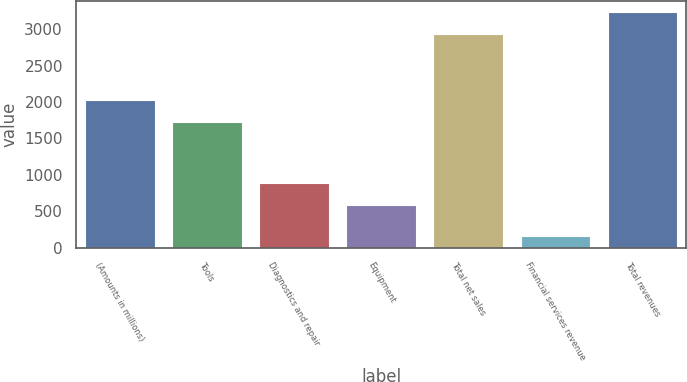Convert chart to OTSL. <chart><loc_0><loc_0><loc_500><loc_500><bar_chart><fcel>(Amounts in millions)<fcel>Tools<fcel>Diagnostics and repair<fcel>Equipment<fcel>Total net sales<fcel>Financial services revenue<fcel>Total revenues<nl><fcel>2023.19<fcel>1729.4<fcel>882.49<fcel>588.7<fcel>2937.9<fcel>161.3<fcel>3231.69<nl></chart> 